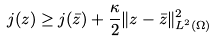Convert formula to latex. <formula><loc_0><loc_0><loc_500><loc_500>j ( z ) \geq j ( \bar { z } ) + \frac { \kappa } { 2 } \| z - \bar { z } \| _ { L ^ { 2 } ( \Omega ) } ^ { 2 }</formula> 